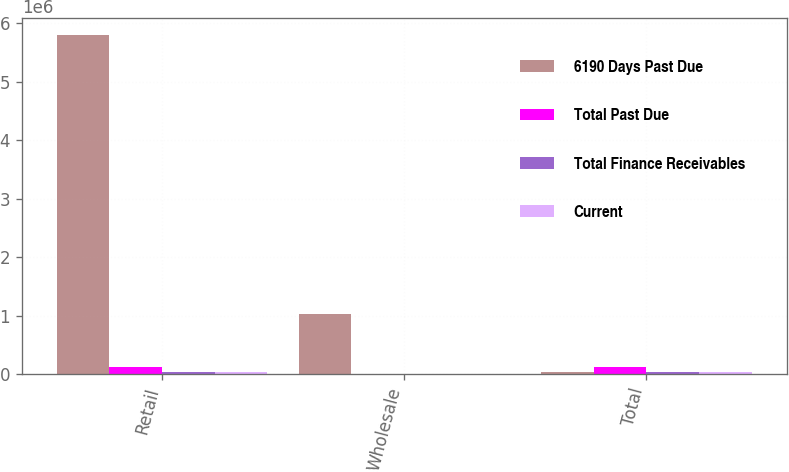<chart> <loc_0><loc_0><loc_500><loc_500><stacked_bar_chart><ecel><fcel>Retail<fcel>Wholesale<fcel>Total<nl><fcel>6190 Days Past Due<fcel>5.796e+06<fcel>1.02236e+06<fcel>43680<nl><fcel>Total Past Due<fcel>118996<fcel>888<fcel>119884<nl><fcel>Total Finance Receivables<fcel>43680<fcel>530<fcel>44210<nl><fcel>Current<fcel>32792<fcel>77<fcel>32869<nl></chart> 